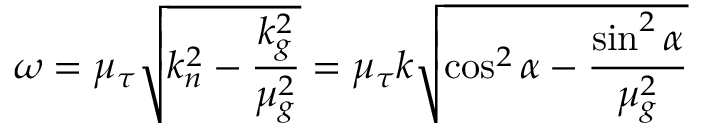<formula> <loc_0><loc_0><loc_500><loc_500>\omega = \mu _ { \tau } { \sqrt { k _ { n } ^ { 2 } - { \frac { k _ { g } ^ { 2 } } { \mu _ { g } ^ { 2 } } } } } = \mu _ { \tau } k { \sqrt { \cos ^ { 2 } \alpha - { \frac { \sin ^ { 2 } \alpha } { \mu _ { g } ^ { 2 } } } } }</formula> 